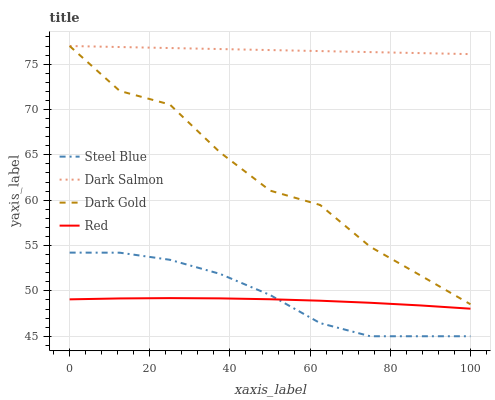Does Red have the minimum area under the curve?
Answer yes or no. Yes. Does Dark Salmon have the maximum area under the curve?
Answer yes or no. Yes. Does Steel Blue have the minimum area under the curve?
Answer yes or no. No. Does Steel Blue have the maximum area under the curve?
Answer yes or no. No. Is Dark Salmon the smoothest?
Answer yes or no. Yes. Is Dark Gold the roughest?
Answer yes or no. Yes. Is Steel Blue the smoothest?
Answer yes or no. No. Is Steel Blue the roughest?
Answer yes or no. No. Does Steel Blue have the lowest value?
Answer yes or no. Yes. Does Red have the lowest value?
Answer yes or no. No. Does Dark Salmon have the highest value?
Answer yes or no. Yes. Does Steel Blue have the highest value?
Answer yes or no. No. Is Steel Blue less than Dark Salmon?
Answer yes or no. Yes. Is Dark Salmon greater than Red?
Answer yes or no. Yes. Does Steel Blue intersect Red?
Answer yes or no. Yes. Is Steel Blue less than Red?
Answer yes or no. No. Is Steel Blue greater than Red?
Answer yes or no. No. Does Steel Blue intersect Dark Salmon?
Answer yes or no. No. 